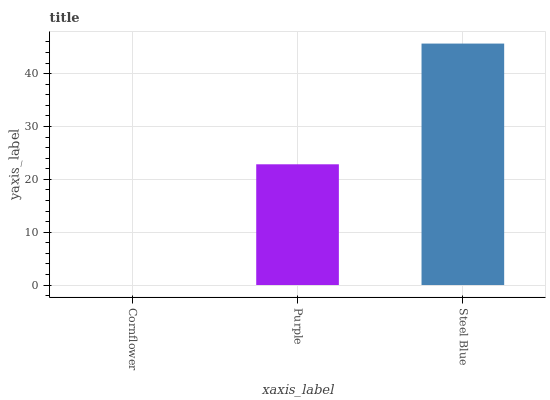Is Cornflower the minimum?
Answer yes or no. Yes. Is Steel Blue the maximum?
Answer yes or no. Yes. Is Purple the minimum?
Answer yes or no. No. Is Purple the maximum?
Answer yes or no. No. Is Purple greater than Cornflower?
Answer yes or no. Yes. Is Cornflower less than Purple?
Answer yes or no. Yes. Is Cornflower greater than Purple?
Answer yes or no. No. Is Purple less than Cornflower?
Answer yes or no. No. Is Purple the high median?
Answer yes or no. Yes. Is Purple the low median?
Answer yes or no. Yes. Is Steel Blue the high median?
Answer yes or no. No. Is Steel Blue the low median?
Answer yes or no. No. 